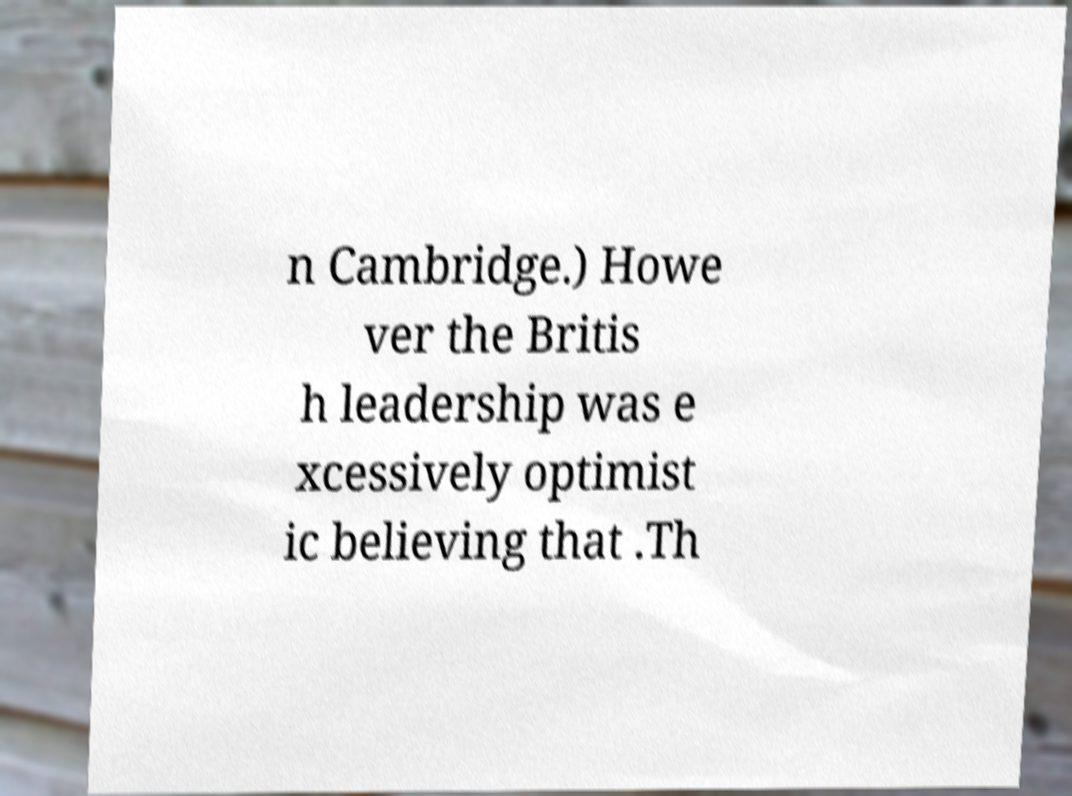Can you read and provide the text displayed in the image?This photo seems to have some interesting text. Can you extract and type it out for me? n Cambridge.) Howe ver the Britis h leadership was e xcessively optimist ic believing that .Th 